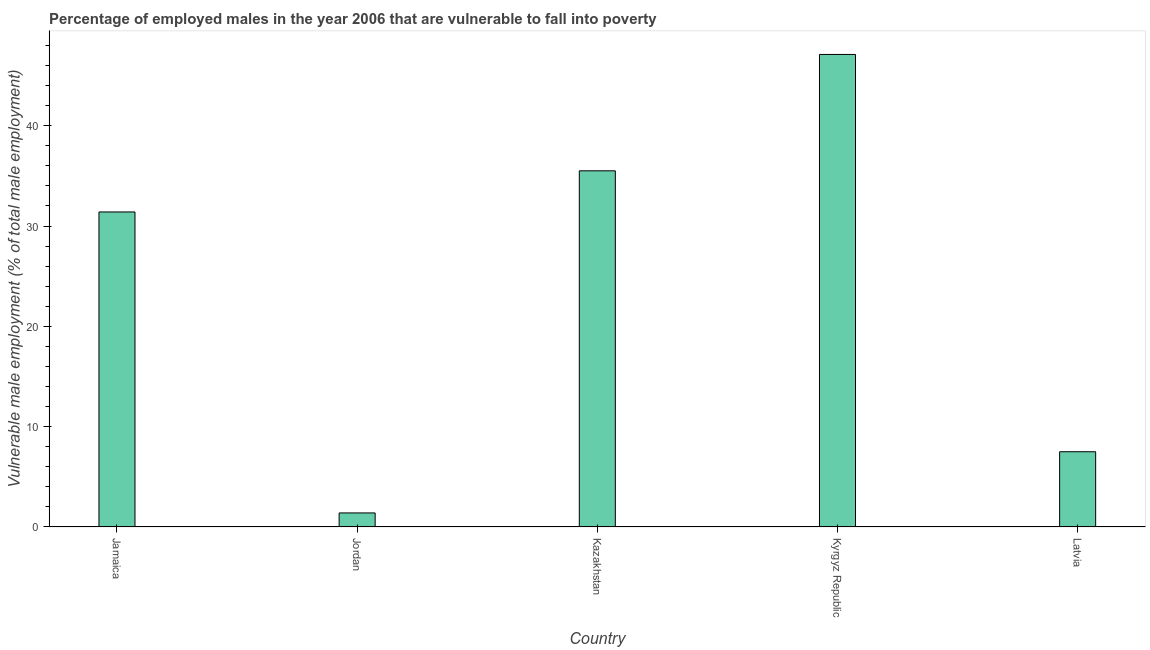What is the title of the graph?
Make the answer very short. Percentage of employed males in the year 2006 that are vulnerable to fall into poverty. What is the label or title of the X-axis?
Your answer should be compact. Country. What is the label or title of the Y-axis?
Give a very brief answer. Vulnerable male employment (% of total male employment). What is the percentage of employed males who are vulnerable to fall into poverty in Kyrgyz Republic?
Your response must be concise. 47.1. Across all countries, what is the maximum percentage of employed males who are vulnerable to fall into poverty?
Ensure brevity in your answer.  47.1. Across all countries, what is the minimum percentage of employed males who are vulnerable to fall into poverty?
Ensure brevity in your answer.  1.4. In which country was the percentage of employed males who are vulnerable to fall into poverty maximum?
Your answer should be very brief. Kyrgyz Republic. In which country was the percentage of employed males who are vulnerable to fall into poverty minimum?
Ensure brevity in your answer.  Jordan. What is the sum of the percentage of employed males who are vulnerable to fall into poverty?
Provide a succinct answer. 122.9. What is the difference between the percentage of employed males who are vulnerable to fall into poverty in Jamaica and Kyrgyz Republic?
Give a very brief answer. -15.7. What is the average percentage of employed males who are vulnerable to fall into poverty per country?
Your answer should be compact. 24.58. What is the median percentage of employed males who are vulnerable to fall into poverty?
Your answer should be compact. 31.4. What is the ratio of the percentage of employed males who are vulnerable to fall into poverty in Jamaica to that in Kyrgyz Republic?
Your answer should be compact. 0.67. What is the difference between the highest and the lowest percentage of employed males who are vulnerable to fall into poverty?
Your answer should be compact. 45.7. How many bars are there?
Ensure brevity in your answer.  5. Are all the bars in the graph horizontal?
Your response must be concise. No. What is the difference between two consecutive major ticks on the Y-axis?
Offer a terse response. 10. Are the values on the major ticks of Y-axis written in scientific E-notation?
Your answer should be very brief. No. What is the Vulnerable male employment (% of total male employment) in Jamaica?
Your answer should be compact. 31.4. What is the Vulnerable male employment (% of total male employment) in Jordan?
Provide a succinct answer. 1.4. What is the Vulnerable male employment (% of total male employment) of Kazakhstan?
Offer a very short reply. 35.5. What is the Vulnerable male employment (% of total male employment) in Kyrgyz Republic?
Make the answer very short. 47.1. What is the Vulnerable male employment (% of total male employment) of Latvia?
Offer a very short reply. 7.5. What is the difference between the Vulnerable male employment (% of total male employment) in Jamaica and Kazakhstan?
Ensure brevity in your answer.  -4.1. What is the difference between the Vulnerable male employment (% of total male employment) in Jamaica and Kyrgyz Republic?
Your answer should be compact. -15.7. What is the difference between the Vulnerable male employment (% of total male employment) in Jamaica and Latvia?
Your answer should be very brief. 23.9. What is the difference between the Vulnerable male employment (% of total male employment) in Jordan and Kazakhstan?
Give a very brief answer. -34.1. What is the difference between the Vulnerable male employment (% of total male employment) in Jordan and Kyrgyz Republic?
Offer a terse response. -45.7. What is the difference between the Vulnerable male employment (% of total male employment) in Jordan and Latvia?
Ensure brevity in your answer.  -6.1. What is the difference between the Vulnerable male employment (% of total male employment) in Kyrgyz Republic and Latvia?
Your answer should be compact. 39.6. What is the ratio of the Vulnerable male employment (% of total male employment) in Jamaica to that in Jordan?
Ensure brevity in your answer.  22.43. What is the ratio of the Vulnerable male employment (% of total male employment) in Jamaica to that in Kazakhstan?
Your answer should be very brief. 0.89. What is the ratio of the Vulnerable male employment (% of total male employment) in Jamaica to that in Kyrgyz Republic?
Offer a terse response. 0.67. What is the ratio of the Vulnerable male employment (% of total male employment) in Jamaica to that in Latvia?
Your response must be concise. 4.19. What is the ratio of the Vulnerable male employment (% of total male employment) in Jordan to that in Kazakhstan?
Offer a very short reply. 0.04. What is the ratio of the Vulnerable male employment (% of total male employment) in Jordan to that in Latvia?
Your answer should be compact. 0.19. What is the ratio of the Vulnerable male employment (% of total male employment) in Kazakhstan to that in Kyrgyz Republic?
Make the answer very short. 0.75. What is the ratio of the Vulnerable male employment (% of total male employment) in Kazakhstan to that in Latvia?
Your response must be concise. 4.73. What is the ratio of the Vulnerable male employment (% of total male employment) in Kyrgyz Republic to that in Latvia?
Provide a succinct answer. 6.28. 